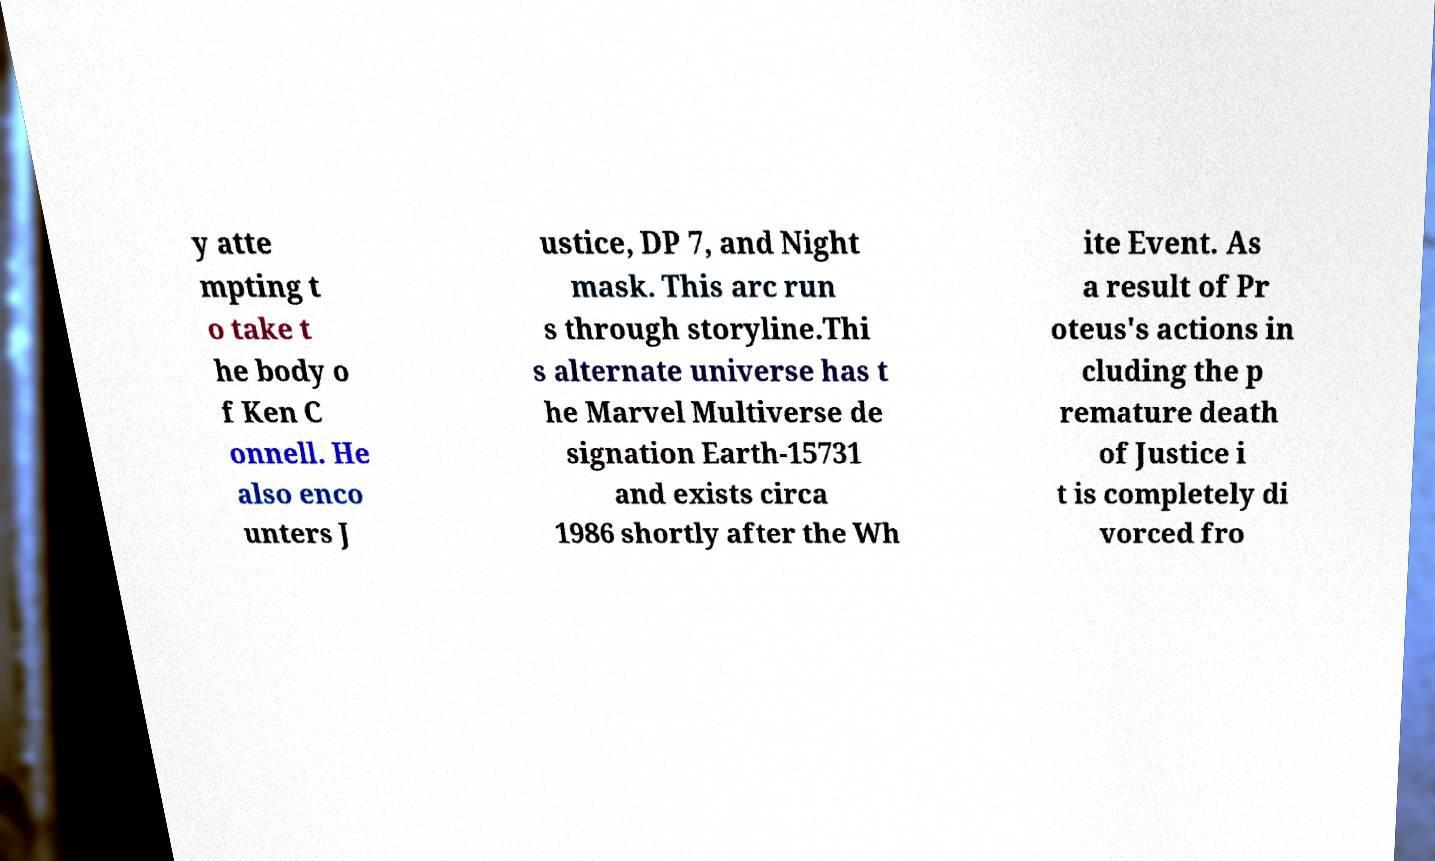Can you accurately transcribe the text from the provided image for me? y atte mpting t o take t he body o f Ken C onnell. He also enco unters J ustice, DP 7, and Night mask. This arc run s through storyline.Thi s alternate universe has t he Marvel Multiverse de signation Earth-15731 and exists circa 1986 shortly after the Wh ite Event. As a result of Pr oteus's actions in cluding the p remature death of Justice i t is completely di vorced fro 